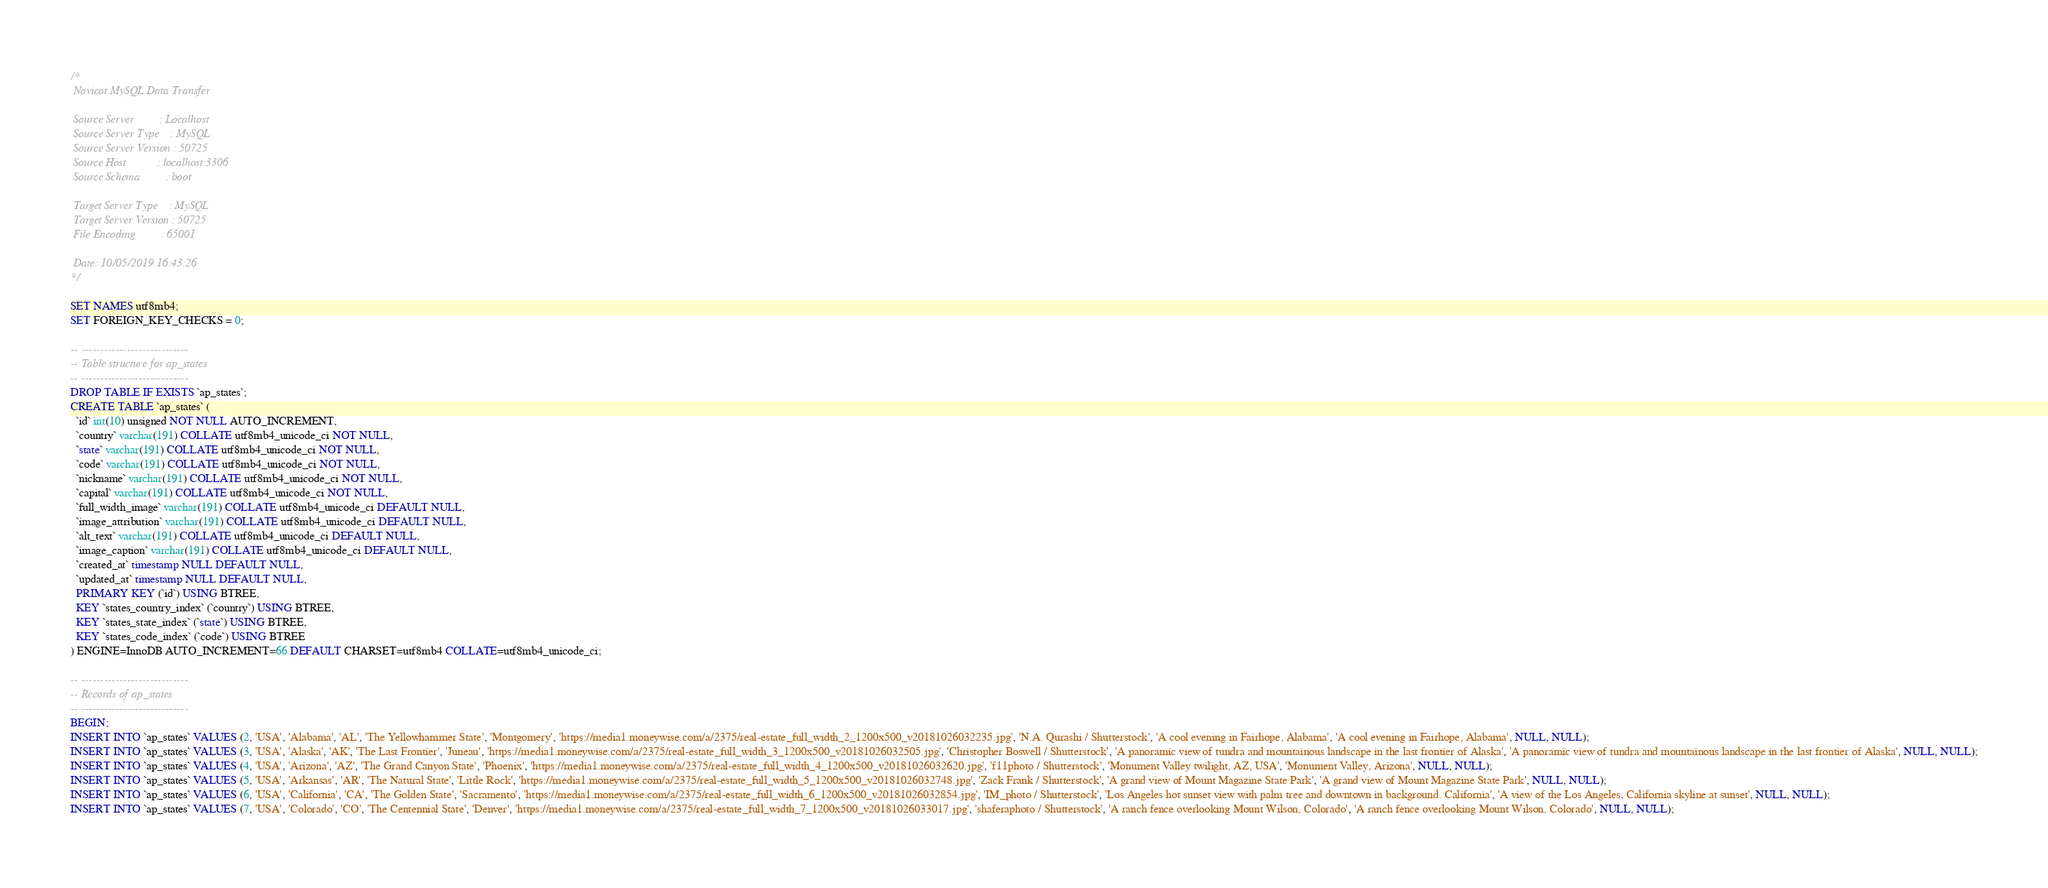Convert code to text. <code><loc_0><loc_0><loc_500><loc_500><_SQL_>/*
 Navicat MySQL Data Transfer

 Source Server         : Localhost
 Source Server Type    : MySQL
 Source Server Version : 50725
 Source Host           : localhost:3306
 Source Schema         : boot

 Target Server Type    : MySQL
 Target Server Version : 50725
 File Encoding         : 65001

 Date: 10/05/2019 16:43:26
*/

SET NAMES utf8mb4;
SET FOREIGN_KEY_CHECKS = 0;

-- ----------------------------
-- Table structure for ap_states
-- ----------------------------
DROP TABLE IF EXISTS `ap_states`;
CREATE TABLE `ap_states` (
  `id` int(10) unsigned NOT NULL AUTO_INCREMENT,
  `country` varchar(191) COLLATE utf8mb4_unicode_ci NOT NULL,
  `state` varchar(191) COLLATE utf8mb4_unicode_ci NOT NULL,
  `code` varchar(191) COLLATE utf8mb4_unicode_ci NOT NULL,
  `nickname` varchar(191) COLLATE utf8mb4_unicode_ci NOT NULL,
  `capital` varchar(191) COLLATE utf8mb4_unicode_ci NOT NULL,
  `full_width_image` varchar(191) COLLATE utf8mb4_unicode_ci DEFAULT NULL,
  `image_attribution` varchar(191) COLLATE utf8mb4_unicode_ci DEFAULT NULL,
  `alt_text` varchar(191) COLLATE utf8mb4_unicode_ci DEFAULT NULL,
  `image_caption` varchar(191) COLLATE utf8mb4_unicode_ci DEFAULT NULL,
  `created_at` timestamp NULL DEFAULT NULL,
  `updated_at` timestamp NULL DEFAULT NULL,
  PRIMARY KEY (`id`) USING BTREE,
  KEY `states_country_index` (`country`) USING BTREE,
  KEY `states_state_index` (`state`) USING BTREE,
  KEY `states_code_index` (`code`) USING BTREE
) ENGINE=InnoDB AUTO_INCREMENT=66 DEFAULT CHARSET=utf8mb4 COLLATE=utf8mb4_unicode_ci;

-- ----------------------------
-- Records of ap_states
-- ----------------------------
BEGIN;
INSERT INTO `ap_states` VALUES (2, 'USA', 'Alabama', 'AL', 'The Yellowhammer State', 'Montgomery', 'https://media1.moneywise.com/a/2375/real-estate_full_width_2_1200x500_v20181026032235.jpg', 'N.A. Qurashi / Shutterstock', 'A cool evening in Fairhope, Alabama', 'A cool evening in Fairhope, Alabama', NULL, NULL);
INSERT INTO `ap_states` VALUES (3, 'USA', 'Alaska', 'AK', 'The Last Frontier', 'Juneau', 'https://media1.moneywise.com/a/2375/real-estate_full_width_3_1200x500_v20181026032505.jpg', 'Christopher Boswell / Shutterstock', 'A panoramic view of tundra and mountainous landscape in the last frontier of Alaska', 'A panoramic view of tundra and mountainous landscape in the last frontier of Alaska', NULL, NULL);
INSERT INTO `ap_states` VALUES (4, 'USA', 'Arizona', 'AZ', 'The Grand Canyon State', 'Phoenix', 'https://media1.moneywise.com/a/2375/real-estate_full_width_4_1200x500_v20181026032620.jpg', 'f11photo / Shutterstock', 'Monument Valley twilight, AZ, USA', 'Monument Valley, Arizona', NULL, NULL);
INSERT INTO `ap_states` VALUES (5, 'USA', 'Arkansas', 'AR', 'The Natural State', 'Little Rock', 'https://media1.moneywise.com/a/2375/real-estate_full_width_5_1200x500_v20181026032748.jpg', 'Zack Frank / Shutterstock', 'A grand view of Mount Magazine State Park', 'A grand view of Mount Magazine State Park', NULL, NULL);
INSERT INTO `ap_states` VALUES (6, 'USA', 'California', 'CA', 'The Golden State', 'Sacramento', 'https://media1.moneywise.com/a/2375/real-estate_full_width_6_1200x500_v20181026032854.jpg', 'IM_photo / Shutterstock', 'Los Angeles hot sunset view with palm tree and downtown in background. California', 'A view of the Los Angeles, California skyline at sunset', NULL, NULL);
INSERT INTO `ap_states` VALUES (7, 'USA', 'Colorado', 'CO', 'The Centennial State', 'Denver', 'https://media1.moneywise.com/a/2375/real-estate_full_width_7_1200x500_v20181026033017.jpg', 'shaferaphoto / Shutterstock', 'A ranch fence overlooking Mount Wilson, Colorado', 'A ranch fence overlooking Mount Wilson, Colorado', NULL, NULL);</code> 